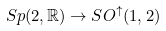Convert formula to latex. <formula><loc_0><loc_0><loc_500><loc_500>S p ( 2 , \mathbb { R } ) \to S O ^ { \uparrow } ( 1 , 2 )</formula> 